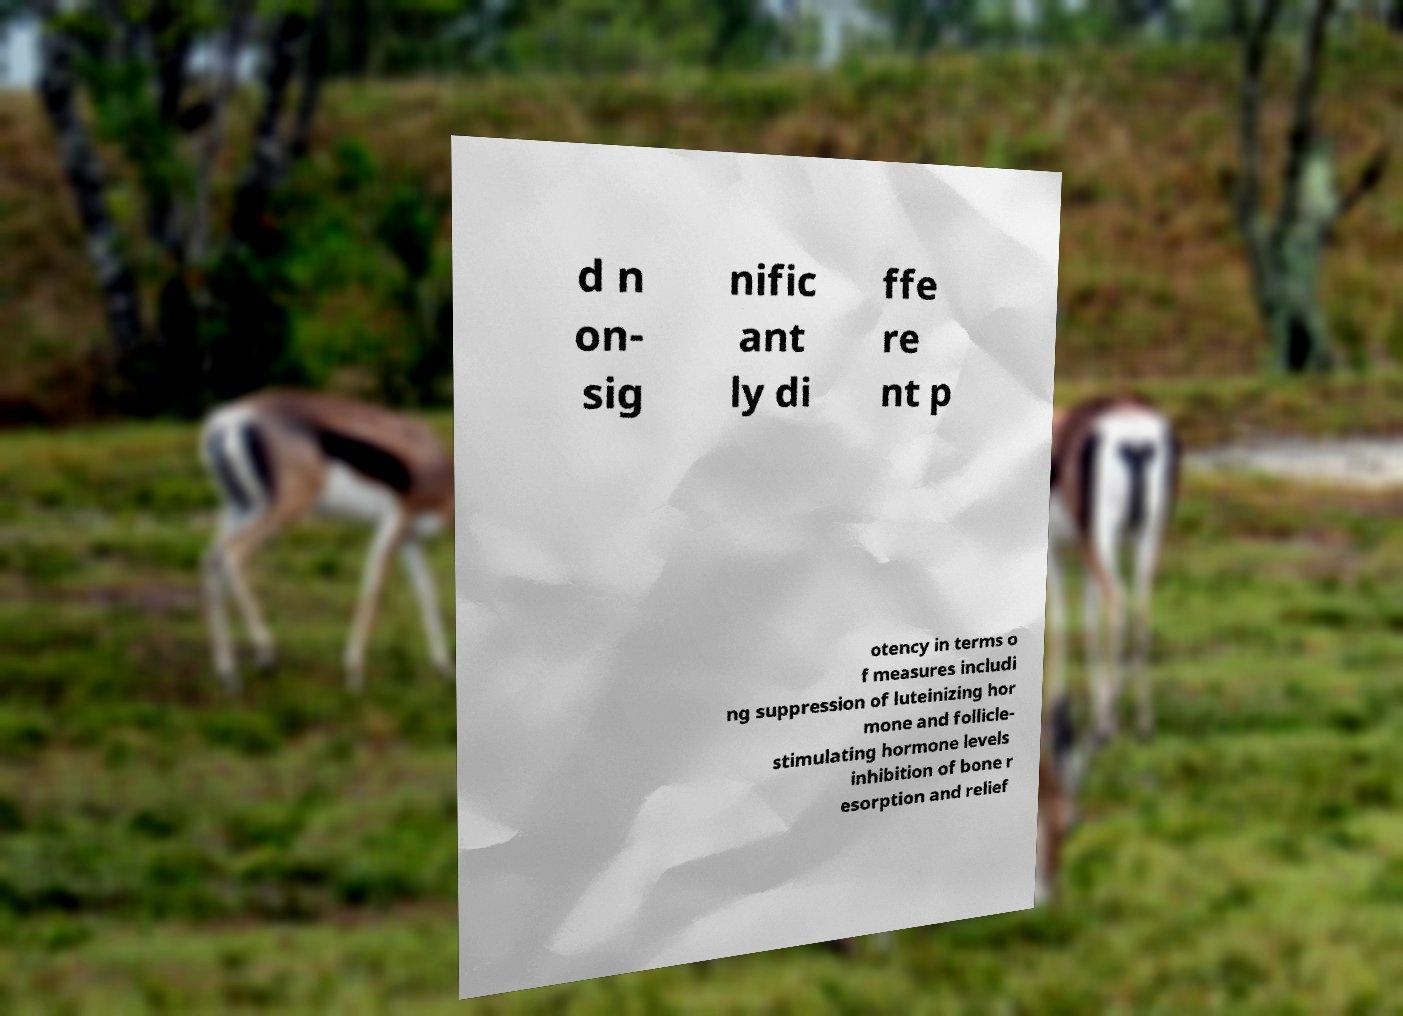Please read and relay the text visible in this image. What does it say? d n on- sig nific ant ly di ffe re nt p otency in terms o f measures includi ng suppression of luteinizing hor mone and follicle- stimulating hormone levels inhibition of bone r esorption and relief 